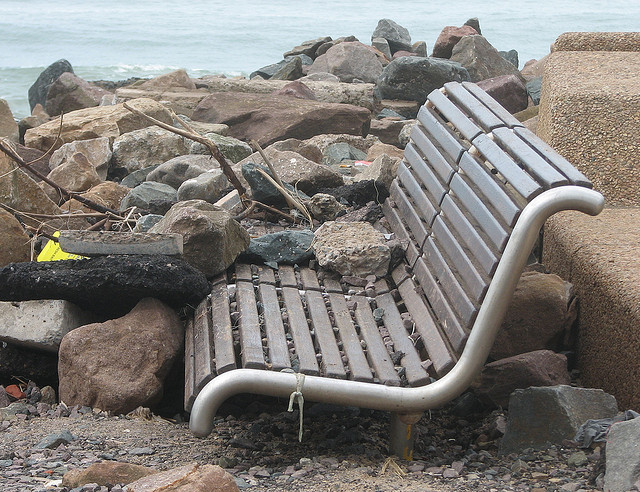Can you describe the surroundings of the bench? The bench is surrounded by a variety of rocks and debris, possibly from a shoreline or riverbank, suggesting it might be at a beach or near a waterway. 